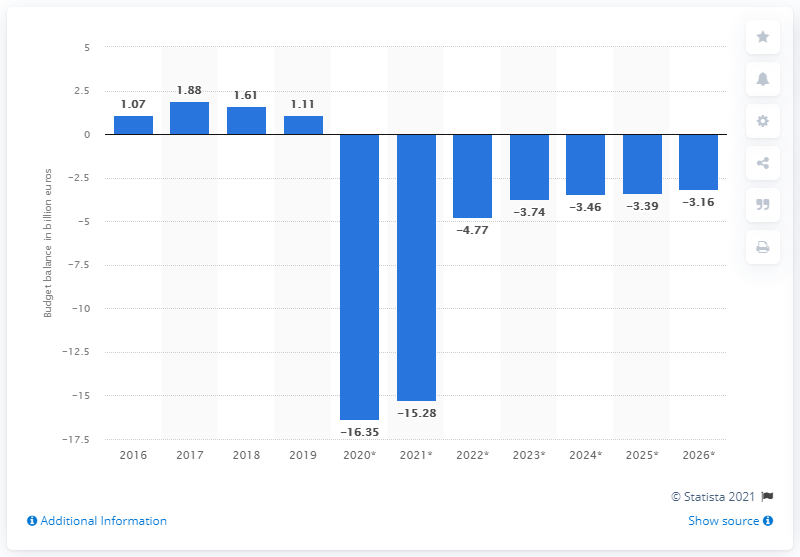Mention a couple of crucial points in this snapshot. In 2019, Greece recorded a budget surplus of 1.11 billion euros. 